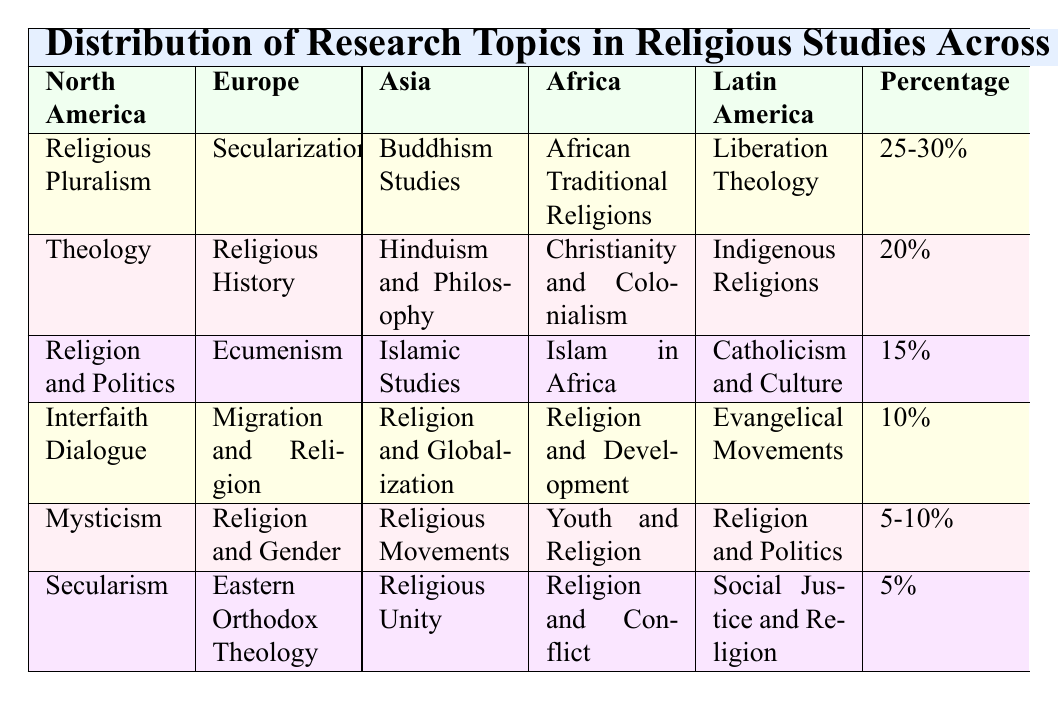What is the most researched topic in North America? The table shows that "Religious Pluralism" has the highest count with 25.
Answer: Religious Pluralism Which research topic has the same percentage in both North America and Latin America? "Religion and Politics" is filtered from both regions, which has a count of 15 in North America and 5 in Latin America, so they have no equal percentage.
Answer: No What are the total counts of research topics for Asia? By adding the counts all research topics in Asia: 25 (Buddhism Studies) + 20 (Hinduism and Philosophy) + 15 (Islamic Studies) + 10 (Religion and Globalization) + 10 (Religious Movements) + 5 (Religious Unity) = 95.
Answer: 95 Is "Islam in Africa" one of the top three research topics in Africa? The top three research topics in Africa with their counts are 30 (African Traditional Religions), 20 (Christianity and Colonialism), and 15 (Islam in Africa), so it is indeed within the top three.
Answer: Yes What is the least researched topic in Europe? The table indicates "Eastern Orthodox Theology" and "Religion and Gender", both have a count of 5, which is the lowest.
Answer: Eastern Orthodox Theology and Religion and Gender Which region has the highest total number of distinct research topics listed? Each region has six distinct research topics listed, so they all have the same total number.
Answer: All regions have the same number What is the difference in the percentage of counts between "Secularization" in Europe and "Religious Pluralism" in North America? "Secularization" has a count of 30, and "Religious Pluralism" has a count of 25. The percentage difference is calculated as 30% - 25% = 5%.
Answer: 5% Which region is studying "Liberation Theology"? According to the table, "Liberation Theology" is a topic found only in Latin America.
Answer: Latin America What percentage of the research topics in Africa focus on "Religion and Development"? The research topic "Religion and Development" counts for 10, out of a total of 100 (summing the count of all topics). Thus its percentage is (10/100)*100 = 10%.
Answer: 10% 